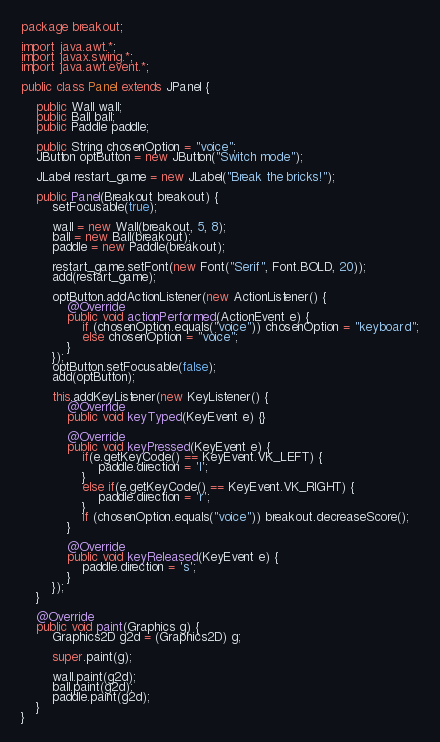Convert code to text. <code><loc_0><loc_0><loc_500><loc_500><_Java_>package breakout;

import java.awt.*;
import javax.swing.*;
import java.awt.event.*;

public class Panel extends JPanel {

    public Wall wall;
    public Ball ball;
    public Paddle paddle;

    public String chosenOption = "voice";
    JButton optButton = new JButton("Switch mode");

    JLabel restart_game = new JLabel("Break the bricks!");

    public Panel(Breakout breakout) {
        setFocusable(true);
        
        wall = new Wall(breakout, 5, 8);
        ball = new Ball(breakout);
        paddle = new Paddle(breakout);

        restart_game.setFont(new Font("Serif", Font.BOLD, 20));
        add(restart_game);

        optButton.addActionListener(new ActionListener() {
            @Override
            public void actionPerformed(ActionEvent e) {
                if (chosenOption.equals("voice")) chosenOption = "keyboard";
                else chosenOption = "voice";
            }
        });
        optButton.setFocusable(false);
        add(optButton);

        this.addKeyListener(new KeyListener() {
            @Override
            public void keyTyped(KeyEvent e) {}

            @Override
            public void keyPressed(KeyEvent e) {
                if(e.getKeyCode() == KeyEvent.VK_LEFT) {
                    paddle.direction = 'l';
                }
                else if(e.getKeyCode() == KeyEvent.VK_RIGHT) {
                    paddle.direction = 'r';
                }
                if (chosenOption.equals("voice")) breakout.decreaseScore();
            }

            @Override
            public void keyReleased(KeyEvent e) {
                paddle.direction = 's';
            }
        });
    }

    @Override
    public void paint(Graphics g) {
        Graphics2D g2d = (Graphics2D) g;

        super.paint(g);

        wall.paint(g2d);
        ball.paint(g2d);
        paddle.paint(g2d);
    }
}
</code> 